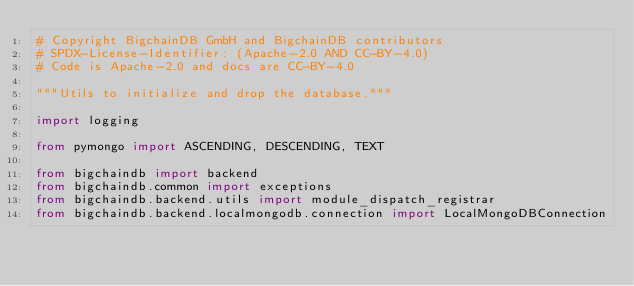Convert code to text. <code><loc_0><loc_0><loc_500><loc_500><_Python_># Copyright BigchainDB GmbH and BigchainDB contributors
# SPDX-License-Identifier: (Apache-2.0 AND CC-BY-4.0)
# Code is Apache-2.0 and docs are CC-BY-4.0

"""Utils to initialize and drop the database."""

import logging

from pymongo import ASCENDING, DESCENDING, TEXT

from bigchaindb import backend
from bigchaindb.common import exceptions
from bigchaindb.backend.utils import module_dispatch_registrar
from bigchaindb.backend.localmongodb.connection import LocalMongoDBConnection

</code> 